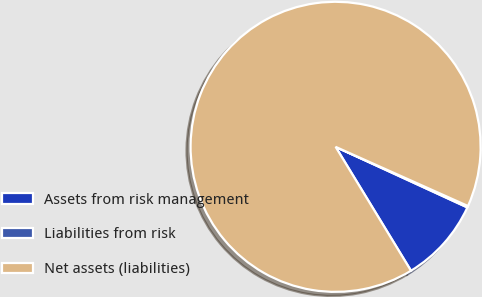Convert chart. <chart><loc_0><loc_0><loc_500><loc_500><pie_chart><fcel>Assets from risk management<fcel>Liabilities from risk<fcel>Net assets (liabilities)<nl><fcel>9.44%<fcel>0.17%<fcel>90.39%<nl></chart> 